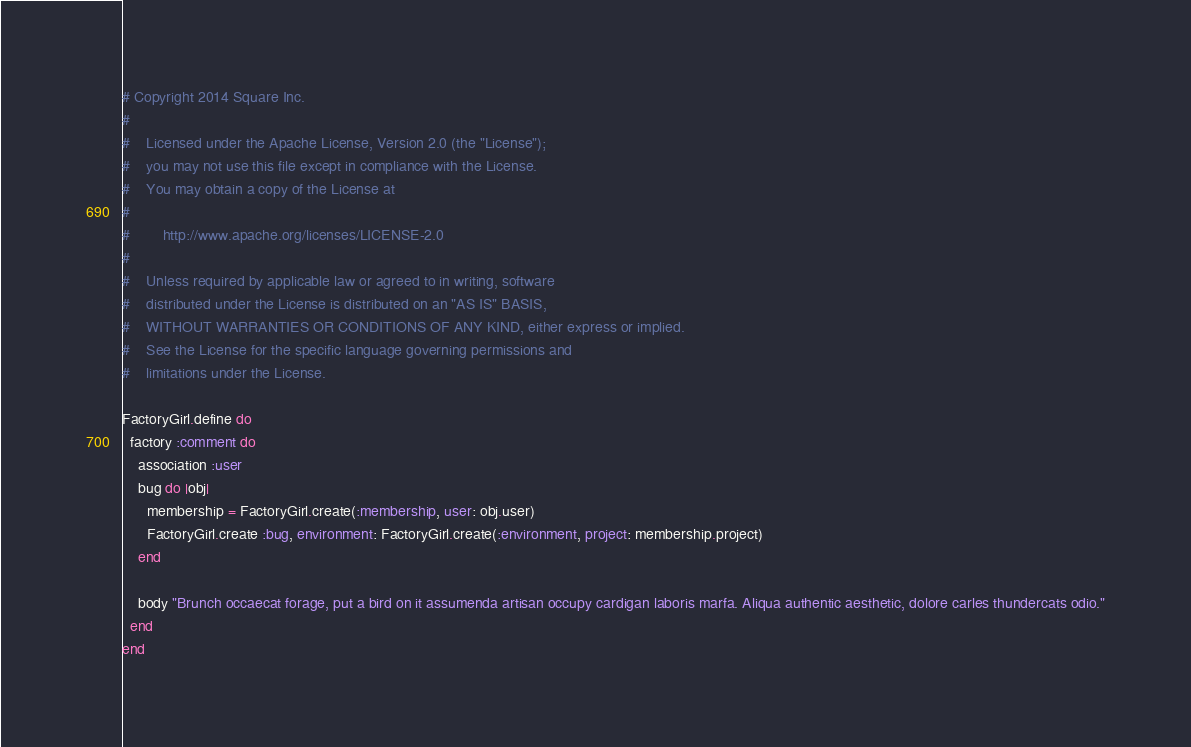<code> <loc_0><loc_0><loc_500><loc_500><_Ruby_># Copyright 2014 Square Inc.
#
#    Licensed under the Apache License, Version 2.0 (the "License");
#    you may not use this file except in compliance with the License.
#    You may obtain a copy of the License at
#
#        http://www.apache.org/licenses/LICENSE-2.0
#
#    Unless required by applicable law or agreed to in writing, software
#    distributed under the License is distributed on an "AS IS" BASIS,
#    WITHOUT WARRANTIES OR CONDITIONS OF ANY KIND, either express or implied.
#    See the License for the specific language governing permissions and
#    limitations under the License.

FactoryGirl.define do
  factory :comment do
    association :user
    bug do |obj|
      membership = FactoryGirl.create(:membership, user: obj.user)
      FactoryGirl.create :bug, environment: FactoryGirl.create(:environment, project: membership.project)
    end

    body "Brunch occaecat forage, put a bird on it assumenda artisan occupy cardigan laboris marfa. Aliqua authentic aesthetic, dolore carles thundercats odio."
  end
end
</code> 